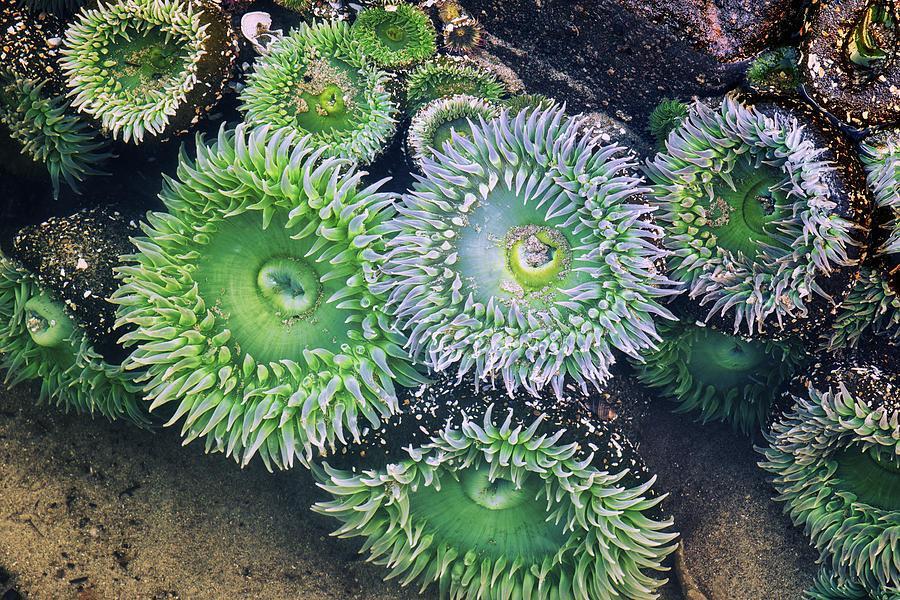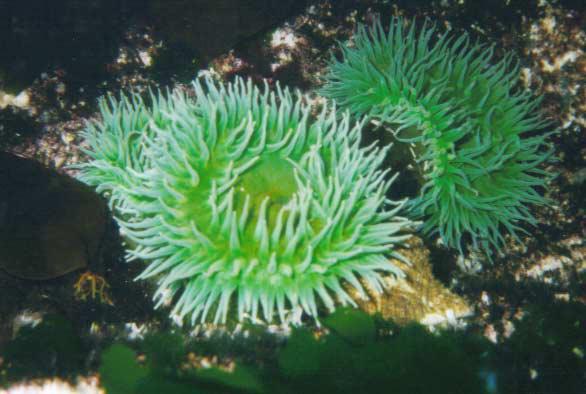The first image is the image on the left, the second image is the image on the right. Considering the images on both sides, is "There are only two Sea anemones" valid? Answer yes or no. No. The first image is the image on the left, the second image is the image on the right. Analyze the images presented: Is the assertion "Left and right images feature one prominent neon-greenish anemone, and a center spot is visible in at least one anemone." valid? Answer yes or no. No. 